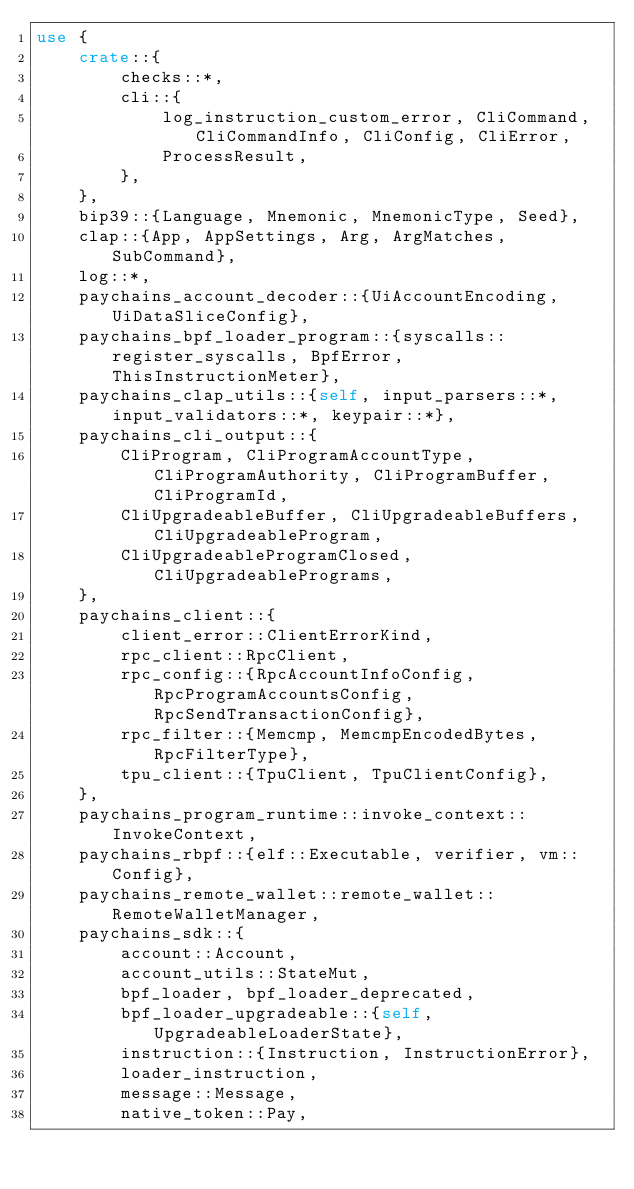Convert code to text. <code><loc_0><loc_0><loc_500><loc_500><_Rust_>use {
    crate::{
        checks::*,
        cli::{
            log_instruction_custom_error, CliCommand, CliCommandInfo, CliConfig, CliError,
            ProcessResult,
        },
    },
    bip39::{Language, Mnemonic, MnemonicType, Seed},
    clap::{App, AppSettings, Arg, ArgMatches, SubCommand},
    log::*,
    paychains_account_decoder::{UiAccountEncoding, UiDataSliceConfig},
    paychains_bpf_loader_program::{syscalls::register_syscalls, BpfError, ThisInstructionMeter},
    paychains_clap_utils::{self, input_parsers::*, input_validators::*, keypair::*},
    paychains_cli_output::{
        CliProgram, CliProgramAccountType, CliProgramAuthority, CliProgramBuffer, CliProgramId,
        CliUpgradeableBuffer, CliUpgradeableBuffers, CliUpgradeableProgram,
        CliUpgradeableProgramClosed, CliUpgradeablePrograms,
    },
    paychains_client::{
        client_error::ClientErrorKind,
        rpc_client::RpcClient,
        rpc_config::{RpcAccountInfoConfig, RpcProgramAccountsConfig, RpcSendTransactionConfig},
        rpc_filter::{Memcmp, MemcmpEncodedBytes, RpcFilterType},
        tpu_client::{TpuClient, TpuClientConfig},
    },
    paychains_program_runtime::invoke_context::InvokeContext,
    paychains_rbpf::{elf::Executable, verifier, vm::Config},
    paychains_remote_wallet::remote_wallet::RemoteWalletManager,
    paychains_sdk::{
        account::Account,
        account_utils::StateMut,
        bpf_loader, bpf_loader_deprecated,
        bpf_loader_upgradeable::{self, UpgradeableLoaderState},
        instruction::{Instruction, InstructionError},
        loader_instruction,
        message::Message,
        native_token::Pay,</code> 